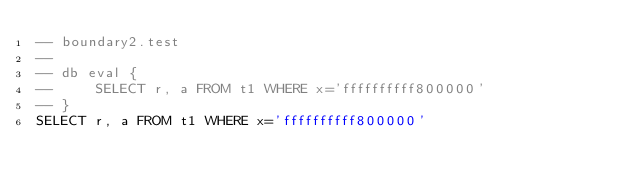Convert code to text. <code><loc_0><loc_0><loc_500><loc_500><_SQL_>-- boundary2.test
-- 
-- db eval {
--     SELECT r, a FROM t1 WHERE x='ffffffffff800000'
-- }
SELECT r, a FROM t1 WHERE x='ffffffffff800000'</code> 